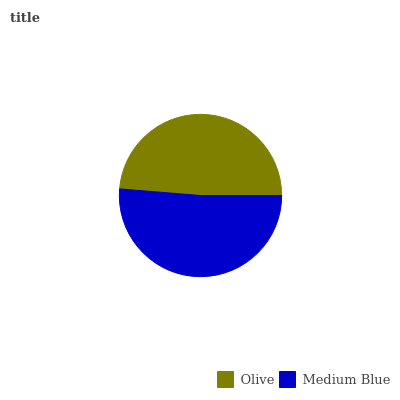Is Olive the minimum?
Answer yes or no. Yes. Is Medium Blue the maximum?
Answer yes or no. Yes. Is Medium Blue the minimum?
Answer yes or no. No. Is Medium Blue greater than Olive?
Answer yes or no. Yes. Is Olive less than Medium Blue?
Answer yes or no. Yes. Is Olive greater than Medium Blue?
Answer yes or no. No. Is Medium Blue less than Olive?
Answer yes or no. No. Is Medium Blue the high median?
Answer yes or no. Yes. Is Olive the low median?
Answer yes or no. Yes. Is Olive the high median?
Answer yes or no. No. Is Medium Blue the low median?
Answer yes or no. No. 